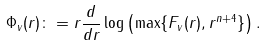Convert formula to latex. <formula><loc_0><loc_0><loc_500><loc_500>\Phi _ { v } ( r ) \colon = r \frac { d } { d r } \log \left ( \max \{ F _ { v } ( r ) , r ^ { n + 4 } \} \right ) .</formula> 